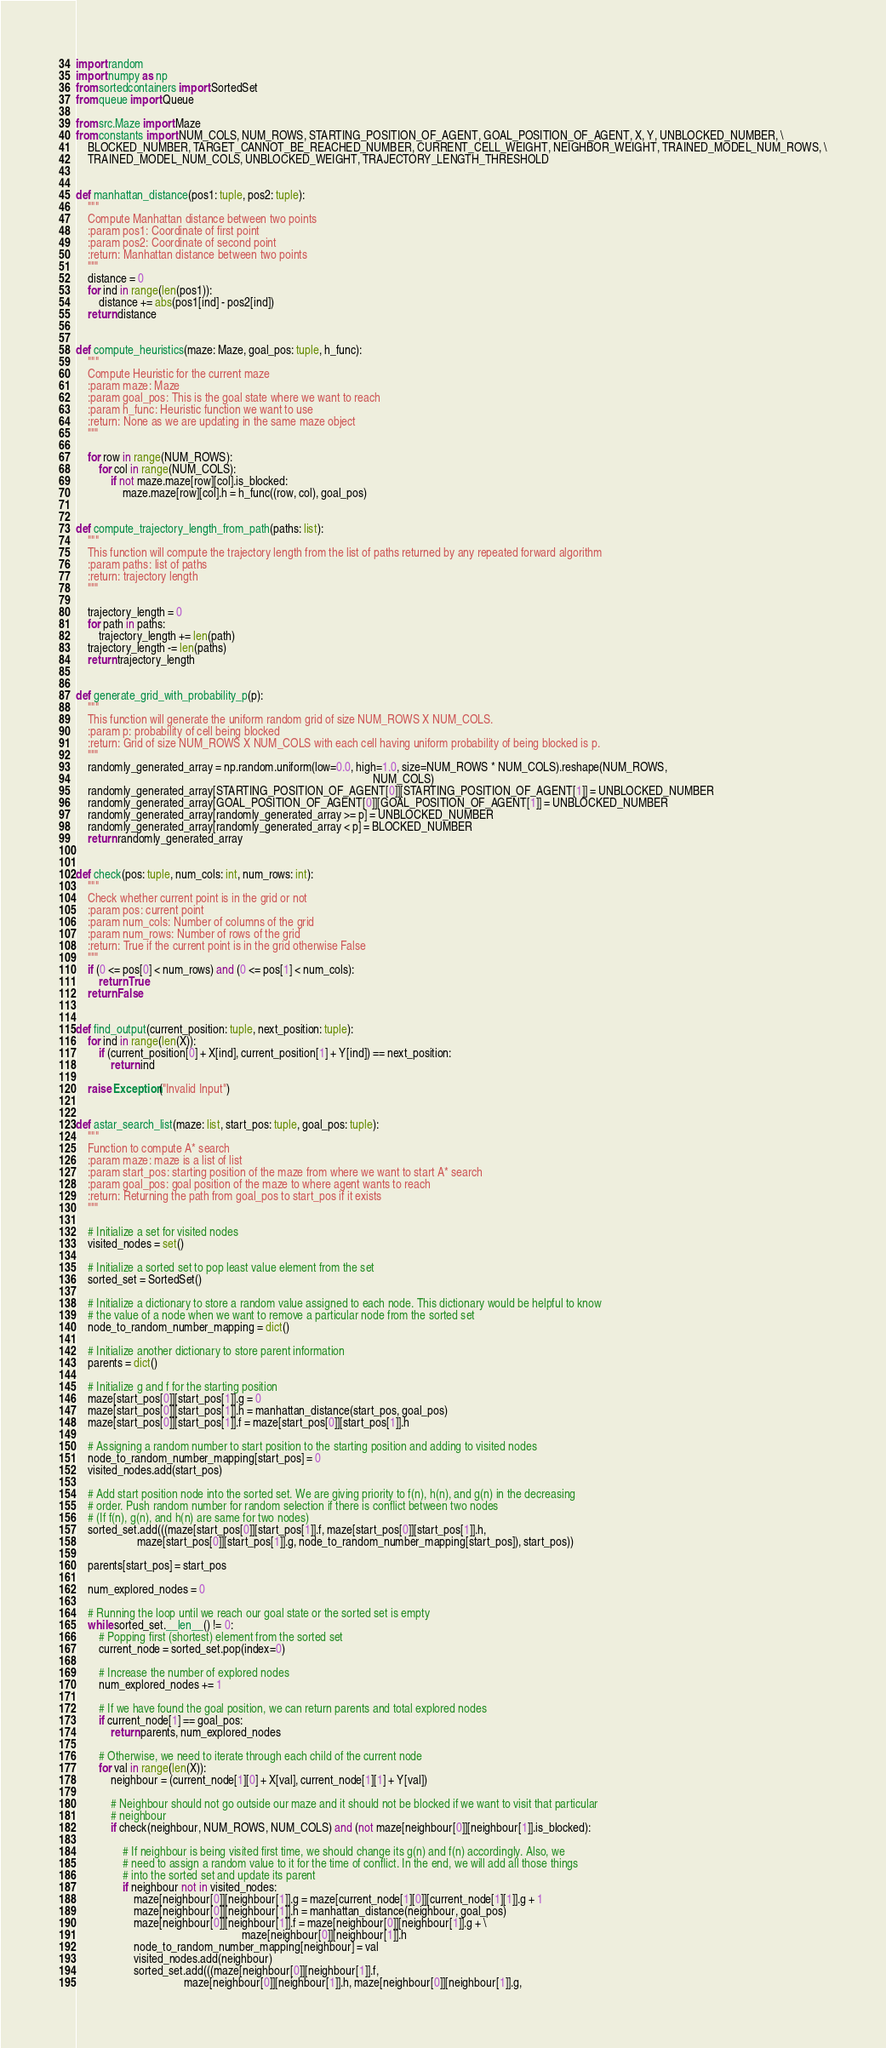Convert code to text. <code><loc_0><loc_0><loc_500><loc_500><_Python_>import random
import numpy as np
from sortedcontainers import SortedSet
from queue import Queue

from src.Maze import Maze
from constants import NUM_COLS, NUM_ROWS, STARTING_POSITION_OF_AGENT, GOAL_POSITION_OF_AGENT, X, Y, UNBLOCKED_NUMBER, \
    BLOCKED_NUMBER, TARGET_CANNOT_BE_REACHED_NUMBER, CURRENT_CELL_WEIGHT, NEIGHBOR_WEIGHT, TRAINED_MODEL_NUM_ROWS, \
    TRAINED_MODEL_NUM_COLS, UNBLOCKED_WEIGHT, TRAJECTORY_LENGTH_THRESHOLD


def manhattan_distance(pos1: tuple, pos2: tuple):
    """
    Compute Manhattan distance between two points
    :param pos1: Coordinate of first point
    :param pos2: Coordinate of second point
    :return: Manhattan distance between two points
    """
    distance = 0
    for ind in range(len(pos1)):
        distance += abs(pos1[ind] - pos2[ind])
    return distance


def compute_heuristics(maze: Maze, goal_pos: tuple, h_func):
    """
    Compute Heuristic for the current maze
    :param maze: Maze
    :param goal_pos: This is the goal state where we want to reach
    :param h_func: Heuristic function we want to use
    :return: None as we are updating in the same maze object
    """

    for row in range(NUM_ROWS):
        for col in range(NUM_COLS):
            if not maze.maze[row][col].is_blocked:
                maze.maze[row][col].h = h_func((row, col), goal_pos)


def compute_trajectory_length_from_path(paths: list):
    """
    This function will compute the trajectory length from the list of paths returned by any repeated forward algorithm
    :param paths: list of paths
    :return: trajectory length
    """

    trajectory_length = 0
    for path in paths:
        trajectory_length += len(path)
    trajectory_length -= len(paths)
    return trajectory_length


def generate_grid_with_probability_p(p):
    """
    This function will generate the uniform random grid of size NUM_ROWS X NUM_COLS.
    :param p: probability of cell being blocked
    :return: Grid of size NUM_ROWS X NUM_COLS with each cell having uniform probability of being blocked is p.
    """
    randomly_generated_array = np.random.uniform(low=0.0, high=1.0, size=NUM_ROWS * NUM_COLS).reshape(NUM_ROWS,
                                                                                                      NUM_COLS)
    randomly_generated_array[STARTING_POSITION_OF_AGENT[0]][STARTING_POSITION_OF_AGENT[1]] = UNBLOCKED_NUMBER
    randomly_generated_array[GOAL_POSITION_OF_AGENT[0]][GOAL_POSITION_OF_AGENT[1]] = UNBLOCKED_NUMBER
    randomly_generated_array[randomly_generated_array >= p] = UNBLOCKED_NUMBER
    randomly_generated_array[randomly_generated_array < p] = BLOCKED_NUMBER
    return randomly_generated_array


def check(pos: tuple, num_cols: int, num_rows: int):
    """
    Check whether current point is in the grid or not
    :param pos: current point
    :param num_cols: Number of columns of the grid
    :param num_rows: Number of rows of the grid
    :return: True if the current point is in the grid otherwise False
    """
    if (0 <= pos[0] < num_rows) and (0 <= pos[1] < num_cols):
        return True
    return False


def find_output(current_position: tuple, next_position: tuple):
    for ind in range(len(X)):
        if (current_position[0] + X[ind], current_position[1] + Y[ind]) == next_position:
            return ind

    raise Exception("Invalid Input")


def astar_search_list(maze: list, start_pos: tuple, goal_pos: tuple):
    """
    Function to compute A* search
    :param maze: maze is a list of list
    :param start_pos: starting position of the maze from where we want to start A* search
    :param goal_pos: goal position of the maze to where agent wants to reach
    :return: Returning the path from goal_pos to start_pos if it exists
    """

    # Initialize a set for visited nodes
    visited_nodes = set()

    # Initialize a sorted set to pop least value element from the set
    sorted_set = SortedSet()

    # Initialize a dictionary to store a random value assigned to each node. This dictionary would be helpful to know
    # the value of a node when we want to remove a particular node from the sorted set
    node_to_random_number_mapping = dict()

    # Initialize another dictionary to store parent information
    parents = dict()

    # Initialize g and f for the starting position
    maze[start_pos[0]][start_pos[1]].g = 0
    maze[start_pos[0]][start_pos[1]].h = manhattan_distance(start_pos, goal_pos)
    maze[start_pos[0]][start_pos[1]].f = maze[start_pos[0]][start_pos[1]].h

    # Assigning a random number to start position to the starting position and adding to visited nodes
    node_to_random_number_mapping[start_pos] = 0
    visited_nodes.add(start_pos)

    # Add start position node into the sorted set. We are giving priority to f(n), h(n), and g(n) in the decreasing
    # order. Push random number for random selection if there is conflict between two nodes
    # (If f(n), g(n), and h(n) are same for two nodes)
    sorted_set.add(((maze[start_pos[0]][start_pos[1]].f, maze[start_pos[0]][start_pos[1]].h,
                     maze[start_pos[0]][start_pos[1]].g, node_to_random_number_mapping[start_pos]), start_pos))

    parents[start_pos] = start_pos

    num_explored_nodes = 0

    # Running the loop until we reach our goal state or the sorted set is empty
    while sorted_set.__len__() != 0:
        # Popping first (shortest) element from the sorted set
        current_node = sorted_set.pop(index=0)

        # Increase the number of explored nodes
        num_explored_nodes += 1

        # If we have found the goal position, we can return parents and total explored nodes
        if current_node[1] == goal_pos:
            return parents, num_explored_nodes

        # Otherwise, we need to iterate through each child of the current node
        for val in range(len(X)):
            neighbour = (current_node[1][0] + X[val], current_node[1][1] + Y[val])

            # Neighbour should not go outside our maze and it should not be blocked if we want to visit that particular
            # neighbour
            if check(neighbour, NUM_ROWS, NUM_COLS) and (not maze[neighbour[0]][neighbour[1]].is_blocked):

                # If neighbour is being visited first time, we should change its g(n) and f(n) accordingly. Also, we
                # need to assign a random value to it for the time of conflict. In the end, we will add all those things
                # into the sorted set and update its parent
                if neighbour not in visited_nodes:
                    maze[neighbour[0]][neighbour[1]].g = maze[current_node[1][0]][current_node[1][1]].g + 1
                    maze[neighbour[0]][neighbour[1]].h = manhattan_distance(neighbour, goal_pos)
                    maze[neighbour[0]][neighbour[1]].f = maze[neighbour[0]][neighbour[1]].g + \
                                                         maze[neighbour[0]][neighbour[1]].h
                    node_to_random_number_mapping[neighbour] = val
                    visited_nodes.add(neighbour)
                    sorted_set.add(((maze[neighbour[0]][neighbour[1]].f,
                                     maze[neighbour[0]][neighbour[1]].h, maze[neighbour[0]][neighbour[1]].g,</code> 